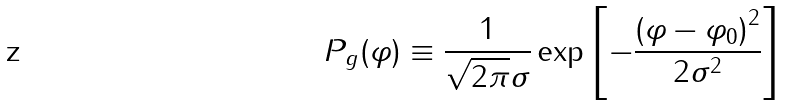Convert formula to latex. <formula><loc_0><loc_0><loc_500><loc_500>P _ { g } ( \varphi ) \equiv \frac { 1 } { \sqrt { 2 \pi } \sigma } \exp \left [ - \frac { \left ( \varphi - \varphi _ { 0 } \right ) ^ { 2 } } { 2 \sigma ^ { 2 } } \right ]</formula> 